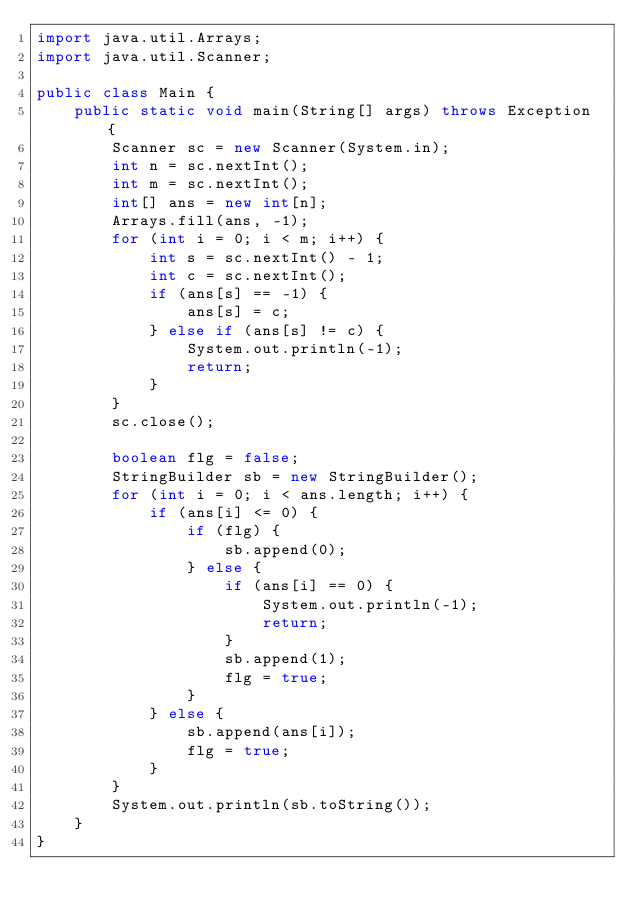<code> <loc_0><loc_0><loc_500><loc_500><_Java_>import java.util.Arrays;
import java.util.Scanner;

public class Main {
	public static void main(String[] args) throws Exception {
		Scanner sc = new Scanner(System.in);
		int n = sc.nextInt();
		int m = sc.nextInt();
		int[] ans = new int[n];
		Arrays.fill(ans, -1);
		for (int i = 0; i < m; i++) {
			int s = sc.nextInt() - 1;
			int c = sc.nextInt();
			if (ans[s] == -1) {
				ans[s] = c;
			} else if (ans[s] != c) {
				System.out.println(-1);
				return;
			}
		}
		sc.close();

		boolean flg = false;
		StringBuilder sb = new StringBuilder();
		for (int i = 0; i < ans.length; i++) {
			if (ans[i] <= 0) {
				if (flg) {
					sb.append(0);
				} else {
					if (ans[i] == 0) {
						System.out.println(-1);
						return;
					}
					sb.append(1);
					flg = true;
				}
			} else {
				sb.append(ans[i]);
				flg = true;
			}
		}
		System.out.println(sb.toString());
	}
}
</code> 